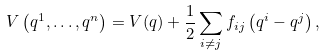Convert formula to latex. <formula><loc_0><loc_0><loc_500><loc_500>V \left ( q ^ { 1 } , \dots , q ^ { n } \right ) = V ( q ) + \frac { 1 } { 2 } \sum _ { i \neq j } f _ { i j } \left ( q ^ { i } - q ^ { j } \right ) ,</formula> 